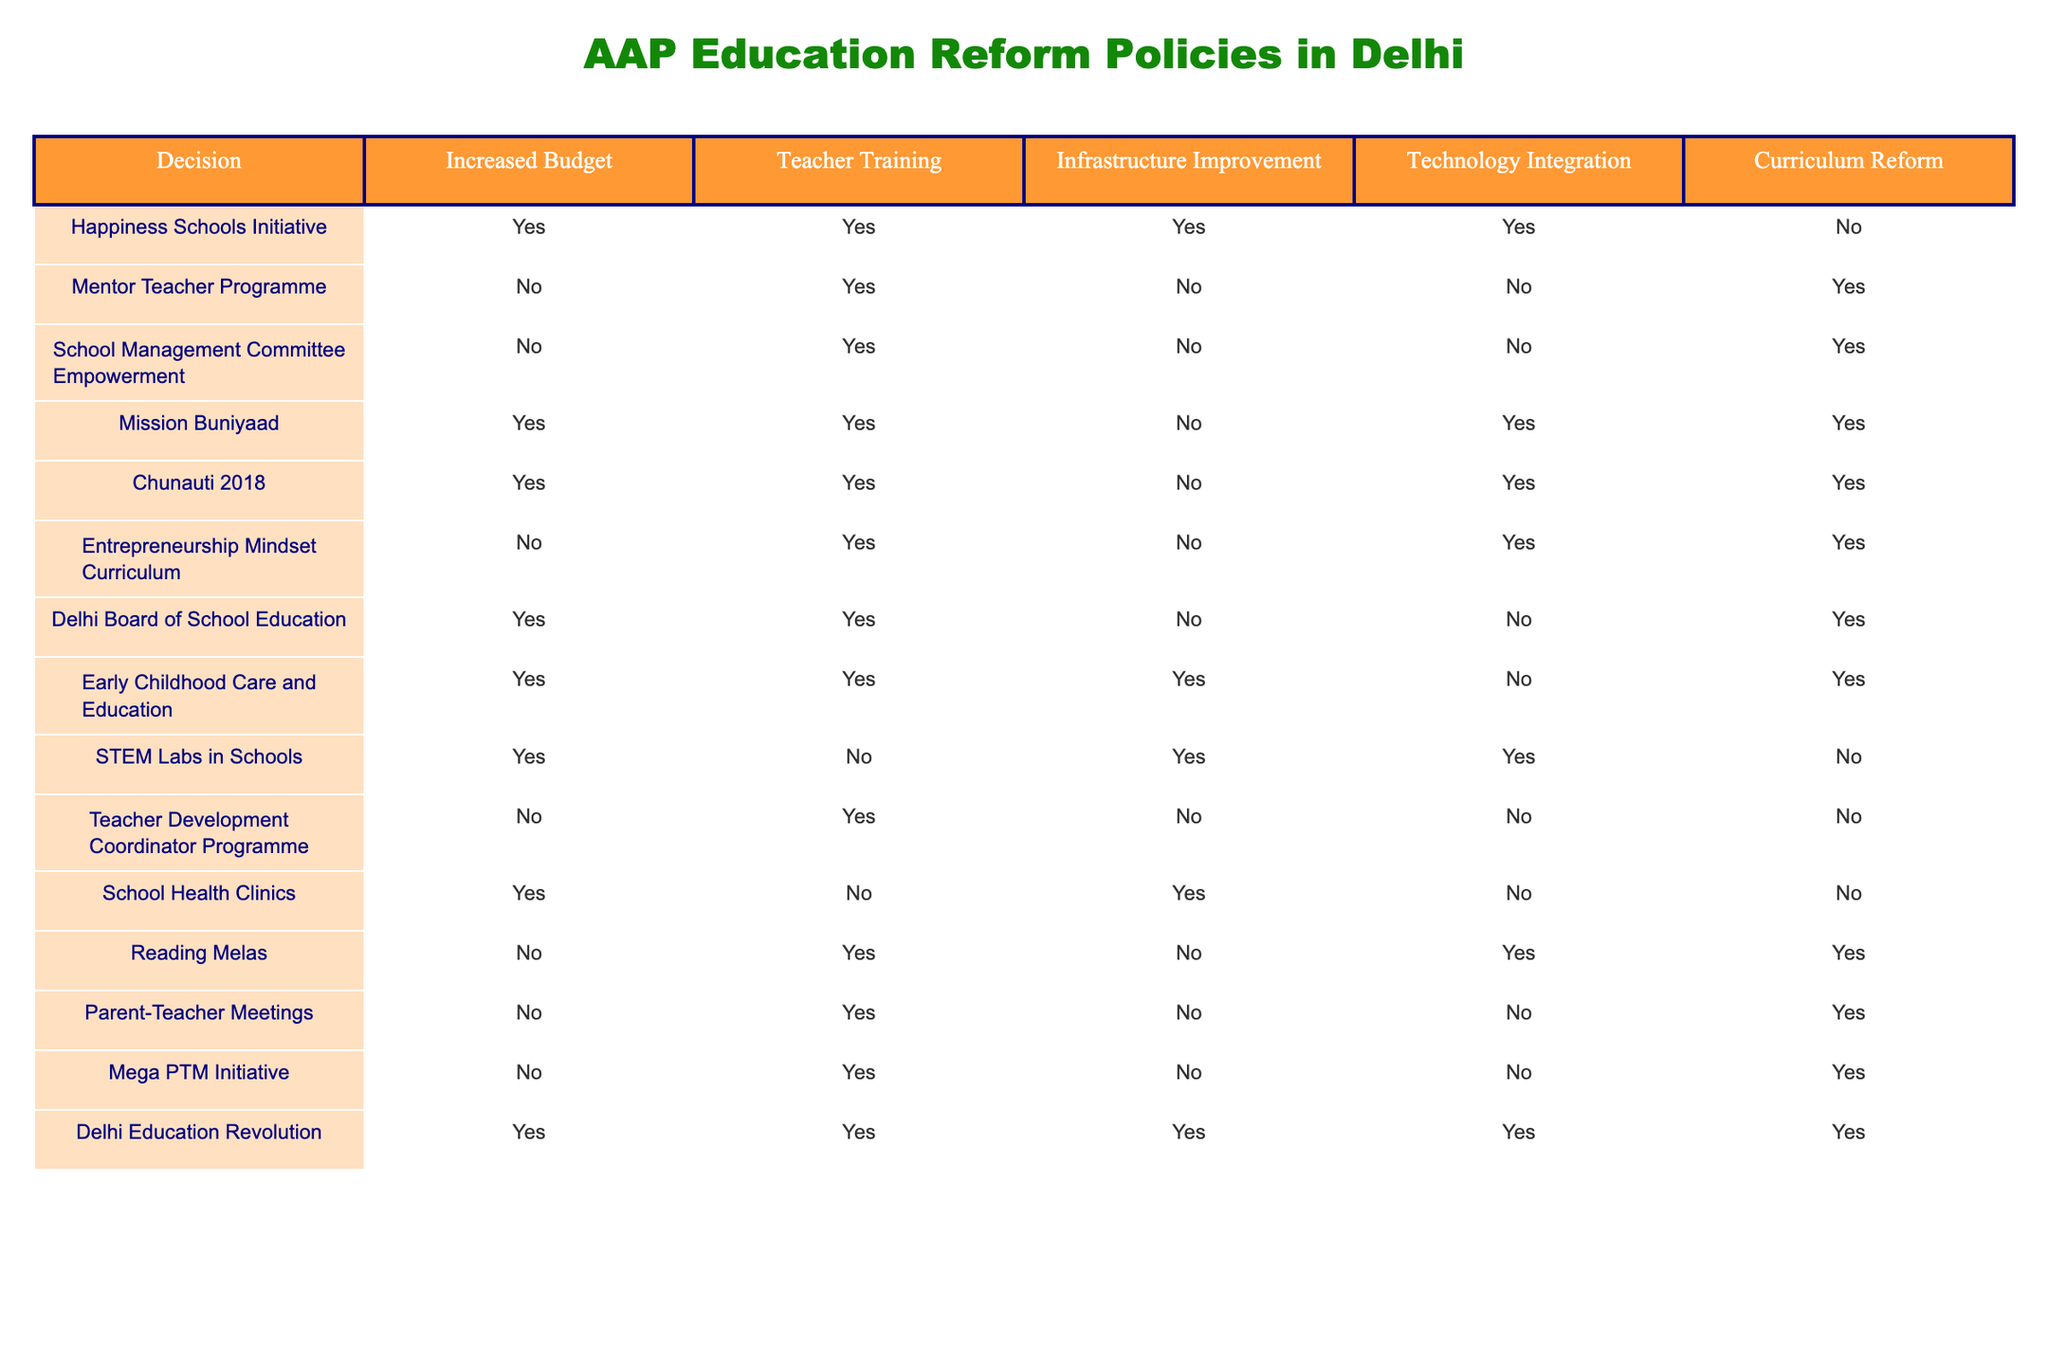What is the total number of initiatives that include "Increased Budget"? To find the total number of initiatives with "Increased Budget," I will count the rows where the "Increased Budget" column has "Yes." The initiatives are Happiness Schools Initiative, Mission Buniyaad, Chunauti 2018, Delhi Board of School Education, Early Childhood Care and Education, STEM Labs in Schools, and Delhi Education Revolution, which gives us a total of 7 initiatives.
Answer: 7 Which initiative includes both "Teacher Training" and "Technology Integration"? By examining the table, I check which initiatives have "Yes" in both the "Teacher Training" and "Technology Integration" columns. Only the Mission Buniyaad, Chunauti 2018, Entrepreneurship Mindset Curriculum, and Delhi Education Revolution initiatives meet this criteria. However, reviewing those carefully, "Entrepreneurship Mindset Curriculum" and "Delhi Education Revolution" have not been mentioned in both, so only Chunauti 2018 fits.
Answer: Chunauti 2018 How many initiatives do not involve any infrastructure improvement? To find the initiatives without infrastructure improvement, I will look for rows where "Infrastructure Improvement" is marked as "No." The pertinent initiatives are the Mentor Teacher Programme, School Management Committee Empowerment, Entrepreneurship Mindset Curriculum, Teacher Development Coordinator Programme, and Mega PTM Initiative, totaling 5 initiatives.
Answer: 5 Is the "Reading Melas" initiative connected with "Curriculum Reform"? I will check the "Curriculum Reform" column for the "Reading Melas" initiative. The table shows that "Reading Melas" has a "Yes" for Teacher Training, a "Yes" for Technology Integration, but it has "No" for Curriculum Reform. Therefore, it is not connected.
Answer: No What percentage of initiatives involve "Technology Integration"? To calculate the percentage of initiatives involving "Technology Integration," I will count the total number of initiatives, which is 10, and the ones with "Yes" in the "Technology Integration" column (Happiness Schools Initiative, Mission Buniyaad, Chunauti 2018, STEM Labs in Schools, and Delhi Education Revolution), which is 5. The percentage is (5/10) * 100 = 50%.
Answer: 50% 